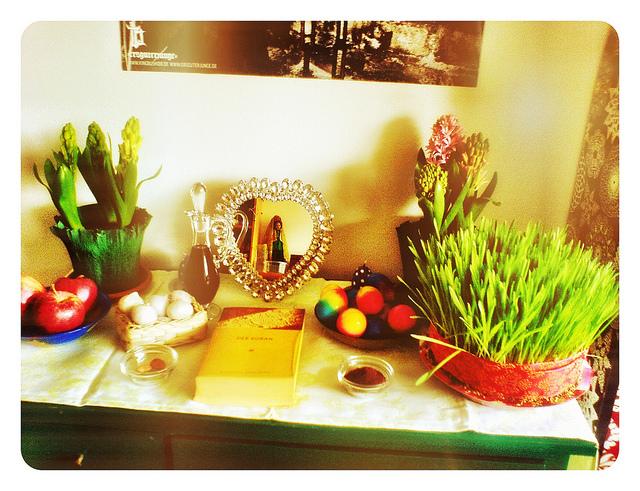Are there any apples on the table?
Give a very brief answer. Yes. What time of year is it?
Quick response, please. Spring. Why is there cloth on top of the dresser?
Write a very short answer. Protection. What shape is that thing just left of center?
Short answer required. Heart. 